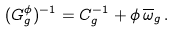Convert formula to latex. <formula><loc_0><loc_0><loc_500><loc_500>( G _ { g } ^ { \phi } ) ^ { - 1 } = C _ { g } ^ { - 1 } + \phi \, \overline { \omega } _ { g } \, .</formula> 